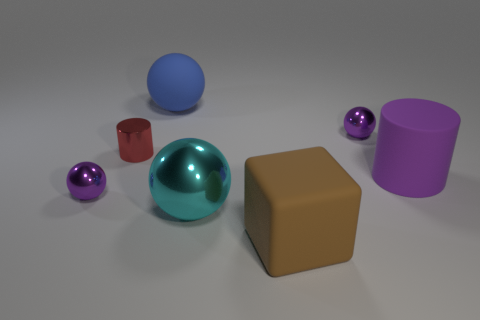Is there any other thing that is the same shape as the brown object?
Keep it short and to the point. No. The small metal thing in front of the large matte cylinder is what color?
Provide a short and direct response. Purple. Are there more small purple spheres to the right of the big brown rubber block than big metallic spheres that are on the left side of the shiny cylinder?
Ensure brevity in your answer.  Yes. There is a shiny ball that is behind the small purple thing that is to the left of the big ball in front of the blue rubber ball; how big is it?
Offer a terse response. Small. Are there any tiny metal balls that have the same color as the large cylinder?
Provide a succinct answer. Yes. How many big rubber blocks are there?
Give a very brief answer. 1. What is the thing that is to the right of the small purple metallic sphere that is right of the matte thing that is in front of the large purple cylinder made of?
Ensure brevity in your answer.  Rubber. Is there another large object made of the same material as the large purple object?
Ensure brevity in your answer.  Yes. Does the blue sphere have the same material as the brown thing?
Your response must be concise. Yes. How many balls are either big blue things or big rubber things?
Give a very brief answer. 1. 